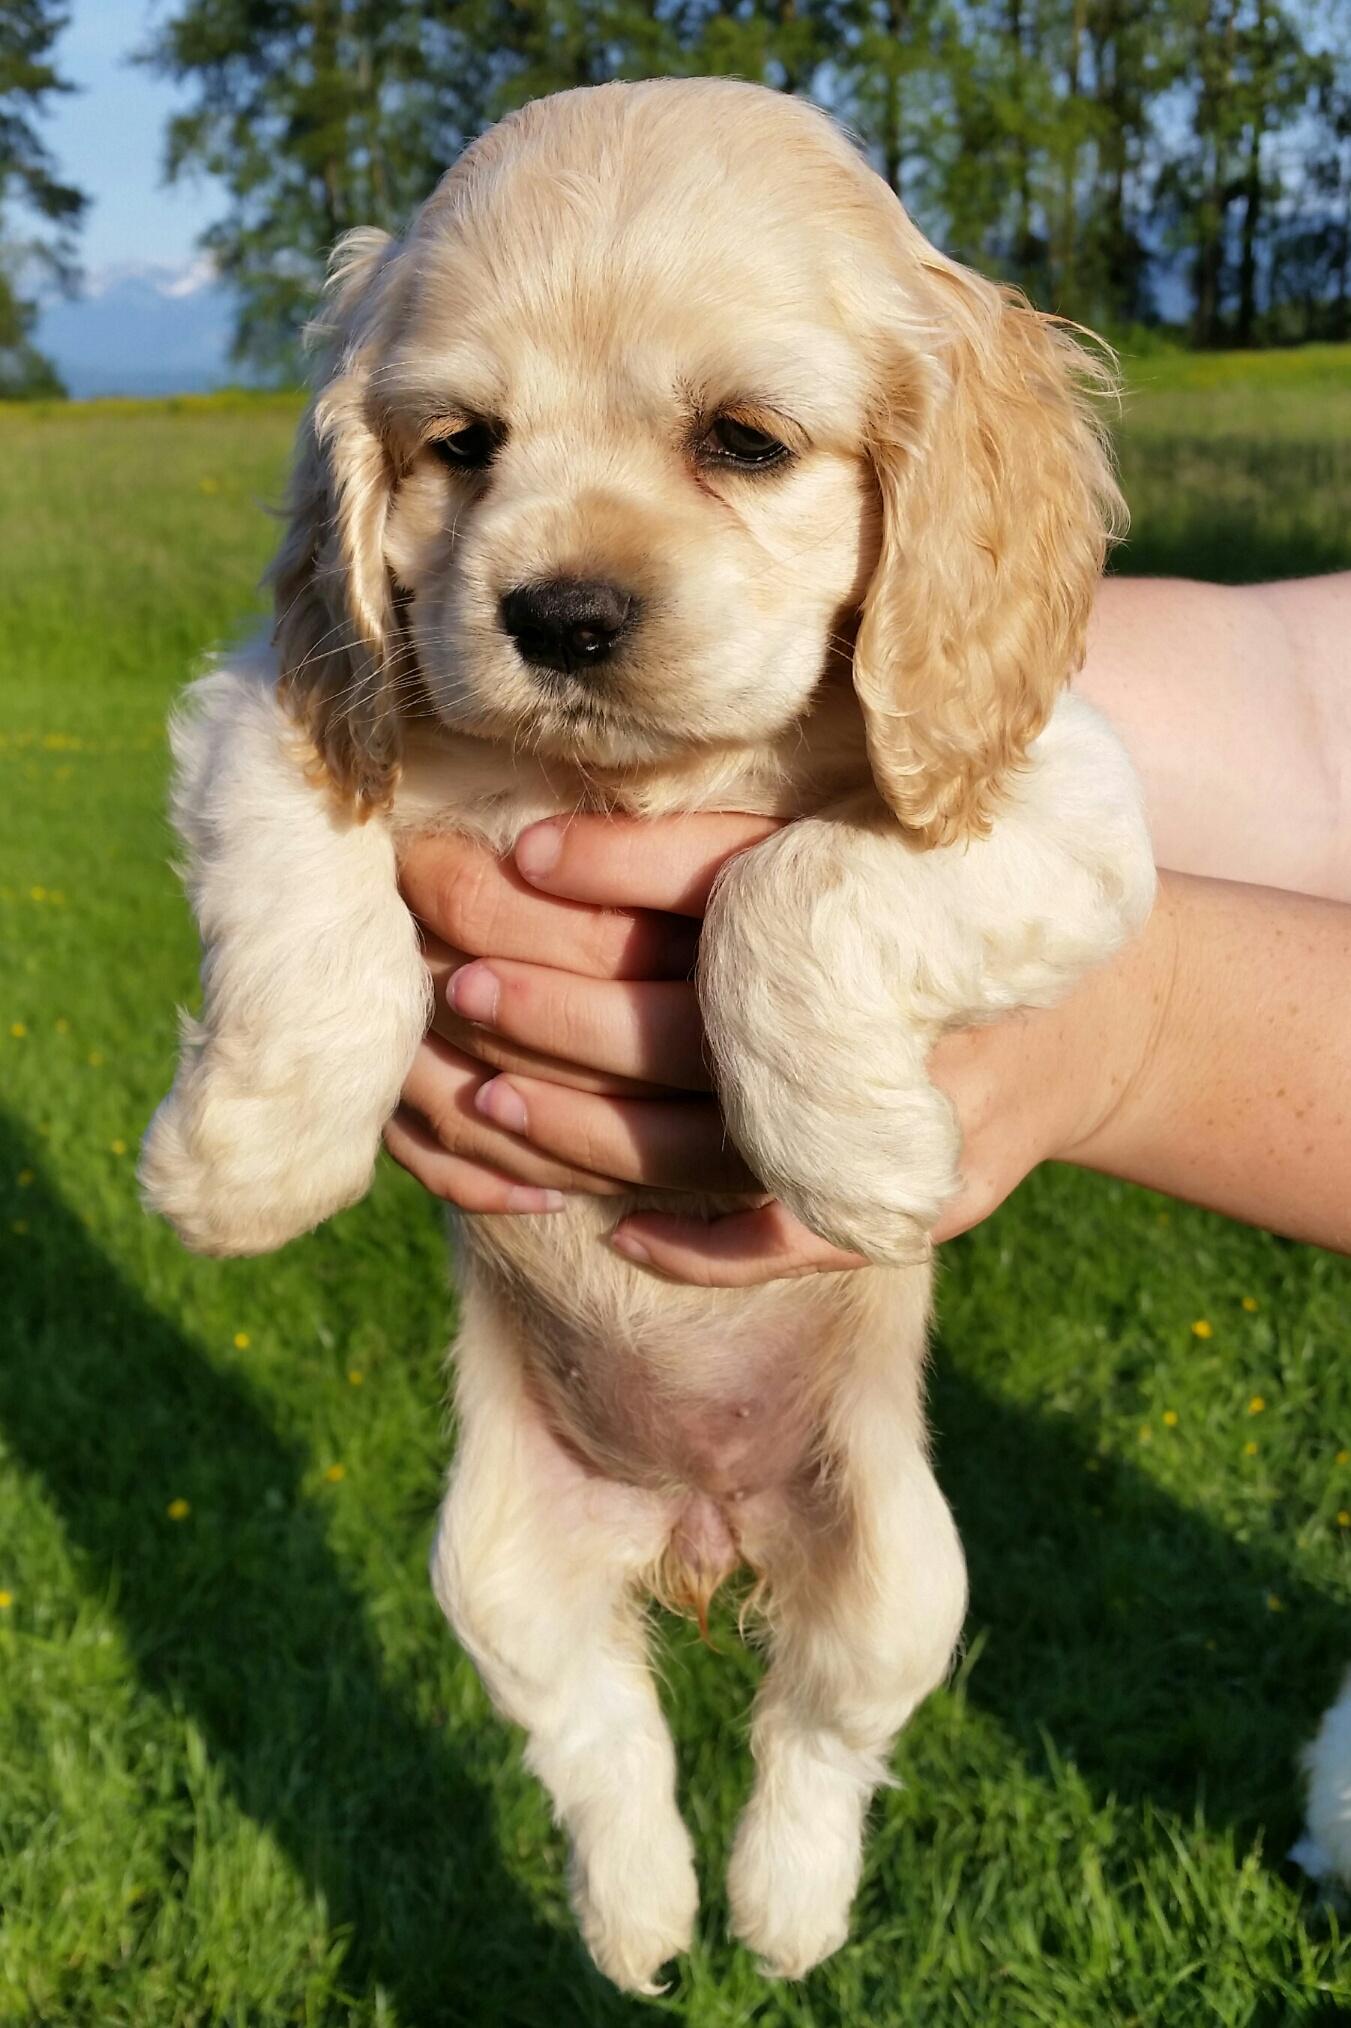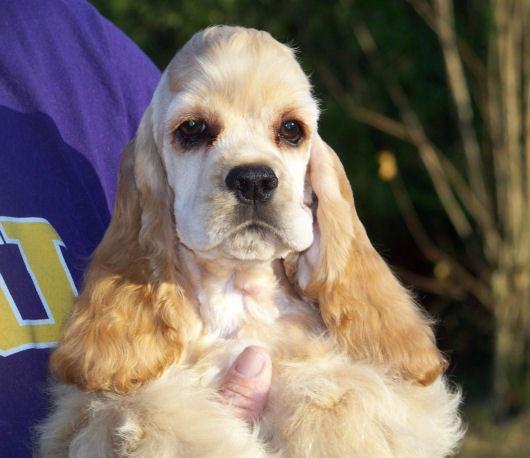The first image is the image on the left, the second image is the image on the right. Evaluate the accuracy of this statement regarding the images: "A hand is holding one spaniel in the left image, while the right image shows at least one spaniel sitting upright.". Is it true? Answer yes or no. No. 